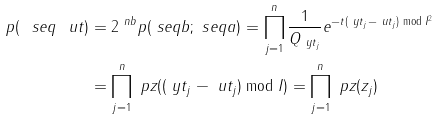<formula> <loc_0><loc_0><loc_500><loc_500>p ( \ s e q { \ u t } ) & = 2 ^ { \ n b } p ( \ s e q { b } ; \ s e q { a } ) = \prod _ { j = 1 } ^ { n } \frac { 1 } { Q _ { \ y t _ { j } } } e ^ { - t ( \ y t _ { j } - \ u t _ { j } ) \bmod I ^ { 2 } } \\ & = \prod _ { j = 1 } ^ { n } \ p z ( ( \ y t _ { j } - \ u t _ { j } ) \bmod I ) = \prod _ { j = 1 } ^ { n } \ p z ( z _ { j } )</formula> 